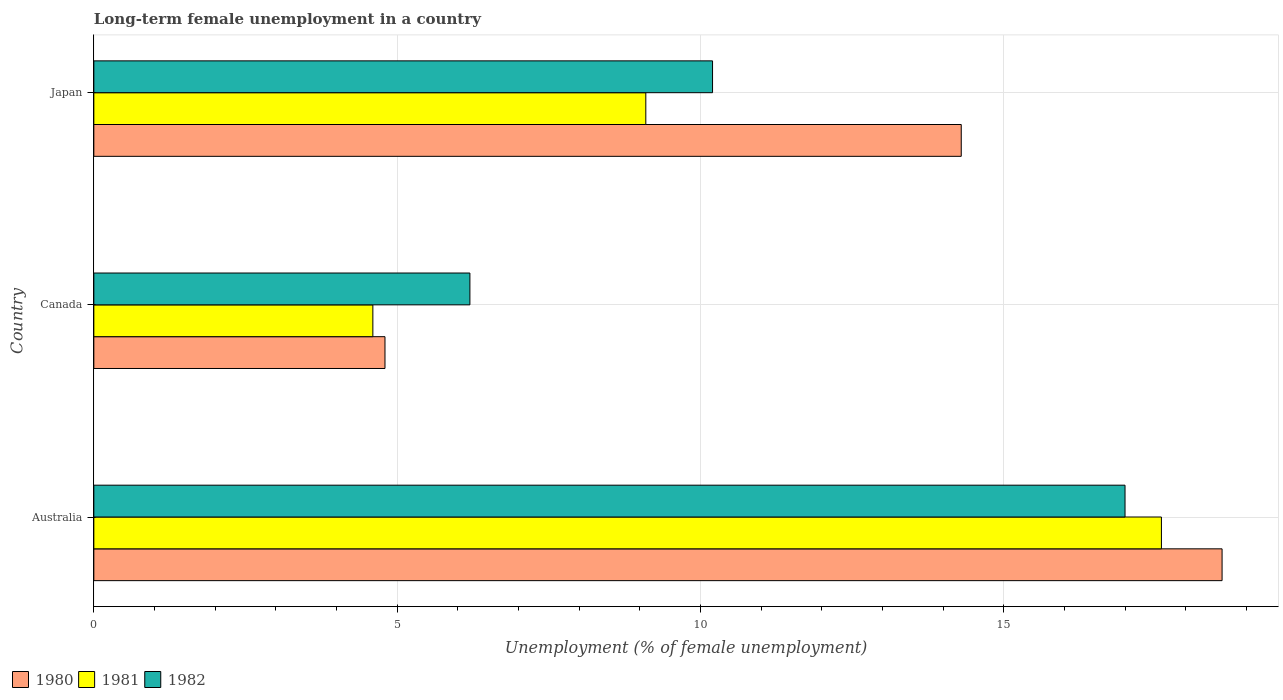How many groups of bars are there?
Offer a terse response. 3. What is the label of the 3rd group of bars from the top?
Your answer should be very brief. Australia. In how many cases, is the number of bars for a given country not equal to the number of legend labels?
Make the answer very short. 0. What is the percentage of long-term unemployed female population in 1980 in Japan?
Your answer should be compact. 14.3. Across all countries, what is the maximum percentage of long-term unemployed female population in 1981?
Keep it short and to the point. 17.6. Across all countries, what is the minimum percentage of long-term unemployed female population in 1982?
Give a very brief answer. 6.2. In which country was the percentage of long-term unemployed female population in 1981 maximum?
Offer a very short reply. Australia. In which country was the percentage of long-term unemployed female population in 1981 minimum?
Your answer should be compact. Canada. What is the total percentage of long-term unemployed female population in 1981 in the graph?
Give a very brief answer. 31.3. What is the difference between the percentage of long-term unemployed female population in 1980 in Australia and that in Japan?
Offer a terse response. 4.3. What is the difference between the percentage of long-term unemployed female population in 1980 in Japan and the percentage of long-term unemployed female population in 1981 in Australia?
Your response must be concise. -3.3. What is the average percentage of long-term unemployed female population in 1981 per country?
Give a very brief answer. 10.43. What is the difference between the percentage of long-term unemployed female population in 1981 and percentage of long-term unemployed female population in 1980 in Australia?
Make the answer very short. -1. In how many countries, is the percentage of long-term unemployed female population in 1981 greater than 9 %?
Give a very brief answer. 2. What is the ratio of the percentage of long-term unemployed female population in 1981 in Canada to that in Japan?
Keep it short and to the point. 0.51. Is the percentage of long-term unemployed female population in 1982 in Australia less than that in Japan?
Your response must be concise. No. Is the difference between the percentage of long-term unemployed female population in 1981 in Australia and Canada greater than the difference between the percentage of long-term unemployed female population in 1980 in Australia and Canada?
Offer a terse response. No. What is the difference between the highest and the second highest percentage of long-term unemployed female population in 1981?
Provide a succinct answer. 8.5. What is the difference between the highest and the lowest percentage of long-term unemployed female population in 1982?
Provide a succinct answer. 10.8. In how many countries, is the percentage of long-term unemployed female population in 1982 greater than the average percentage of long-term unemployed female population in 1982 taken over all countries?
Your answer should be very brief. 1. What does the 2nd bar from the bottom in Japan represents?
Your answer should be very brief. 1981. Are all the bars in the graph horizontal?
Your response must be concise. Yes. Does the graph contain any zero values?
Your answer should be compact. No. Where does the legend appear in the graph?
Provide a short and direct response. Bottom left. How many legend labels are there?
Make the answer very short. 3. How are the legend labels stacked?
Your answer should be compact. Horizontal. What is the title of the graph?
Offer a very short reply. Long-term female unemployment in a country. What is the label or title of the X-axis?
Your answer should be very brief. Unemployment (% of female unemployment). What is the label or title of the Y-axis?
Keep it short and to the point. Country. What is the Unemployment (% of female unemployment) of 1980 in Australia?
Your response must be concise. 18.6. What is the Unemployment (% of female unemployment) of 1981 in Australia?
Ensure brevity in your answer.  17.6. What is the Unemployment (% of female unemployment) of 1982 in Australia?
Your response must be concise. 17. What is the Unemployment (% of female unemployment) of 1980 in Canada?
Keep it short and to the point. 4.8. What is the Unemployment (% of female unemployment) in 1981 in Canada?
Make the answer very short. 4.6. What is the Unemployment (% of female unemployment) of 1982 in Canada?
Your response must be concise. 6.2. What is the Unemployment (% of female unemployment) in 1980 in Japan?
Provide a succinct answer. 14.3. What is the Unemployment (% of female unemployment) of 1981 in Japan?
Provide a succinct answer. 9.1. What is the Unemployment (% of female unemployment) in 1982 in Japan?
Offer a very short reply. 10.2. Across all countries, what is the maximum Unemployment (% of female unemployment) in 1980?
Ensure brevity in your answer.  18.6. Across all countries, what is the maximum Unemployment (% of female unemployment) of 1981?
Give a very brief answer. 17.6. Across all countries, what is the minimum Unemployment (% of female unemployment) in 1980?
Make the answer very short. 4.8. Across all countries, what is the minimum Unemployment (% of female unemployment) of 1981?
Ensure brevity in your answer.  4.6. Across all countries, what is the minimum Unemployment (% of female unemployment) of 1982?
Your response must be concise. 6.2. What is the total Unemployment (% of female unemployment) of 1980 in the graph?
Your response must be concise. 37.7. What is the total Unemployment (% of female unemployment) in 1981 in the graph?
Offer a terse response. 31.3. What is the total Unemployment (% of female unemployment) of 1982 in the graph?
Ensure brevity in your answer.  33.4. What is the difference between the Unemployment (% of female unemployment) in 1981 in Australia and that in Canada?
Offer a very short reply. 13. What is the difference between the Unemployment (% of female unemployment) of 1981 in Australia and that in Japan?
Provide a succinct answer. 8.5. What is the difference between the Unemployment (% of female unemployment) of 1982 in Australia and that in Japan?
Offer a very short reply. 6.8. What is the difference between the Unemployment (% of female unemployment) in 1980 in Canada and that in Japan?
Keep it short and to the point. -9.5. What is the difference between the Unemployment (% of female unemployment) of 1982 in Canada and that in Japan?
Offer a very short reply. -4. What is the difference between the Unemployment (% of female unemployment) in 1980 in Australia and the Unemployment (% of female unemployment) in 1981 in Canada?
Provide a succinct answer. 14. What is the difference between the Unemployment (% of female unemployment) of 1980 in Australia and the Unemployment (% of female unemployment) of 1982 in Canada?
Provide a short and direct response. 12.4. What is the difference between the Unemployment (% of female unemployment) in 1981 in Australia and the Unemployment (% of female unemployment) in 1982 in Canada?
Your answer should be very brief. 11.4. What is the difference between the Unemployment (% of female unemployment) of 1980 in Australia and the Unemployment (% of female unemployment) of 1981 in Japan?
Offer a very short reply. 9.5. What is the difference between the Unemployment (% of female unemployment) in 1980 in Australia and the Unemployment (% of female unemployment) in 1982 in Japan?
Offer a terse response. 8.4. What is the difference between the Unemployment (% of female unemployment) in 1980 in Canada and the Unemployment (% of female unemployment) in 1982 in Japan?
Give a very brief answer. -5.4. What is the difference between the Unemployment (% of female unemployment) of 1981 in Canada and the Unemployment (% of female unemployment) of 1982 in Japan?
Provide a succinct answer. -5.6. What is the average Unemployment (% of female unemployment) in 1980 per country?
Give a very brief answer. 12.57. What is the average Unemployment (% of female unemployment) of 1981 per country?
Keep it short and to the point. 10.43. What is the average Unemployment (% of female unemployment) in 1982 per country?
Your answer should be very brief. 11.13. What is the difference between the Unemployment (% of female unemployment) in 1980 and Unemployment (% of female unemployment) in 1981 in Australia?
Your answer should be compact. 1. What is the difference between the Unemployment (% of female unemployment) in 1981 and Unemployment (% of female unemployment) in 1982 in Australia?
Your answer should be compact. 0.6. What is the difference between the Unemployment (% of female unemployment) of 1981 and Unemployment (% of female unemployment) of 1982 in Canada?
Offer a terse response. -1.6. What is the difference between the Unemployment (% of female unemployment) in 1980 and Unemployment (% of female unemployment) in 1982 in Japan?
Keep it short and to the point. 4.1. What is the ratio of the Unemployment (% of female unemployment) in 1980 in Australia to that in Canada?
Offer a terse response. 3.88. What is the ratio of the Unemployment (% of female unemployment) in 1981 in Australia to that in Canada?
Make the answer very short. 3.83. What is the ratio of the Unemployment (% of female unemployment) of 1982 in Australia to that in Canada?
Your answer should be compact. 2.74. What is the ratio of the Unemployment (% of female unemployment) of 1980 in Australia to that in Japan?
Keep it short and to the point. 1.3. What is the ratio of the Unemployment (% of female unemployment) of 1981 in Australia to that in Japan?
Provide a succinct answer. 1.93. What is the ratio of the Unemployment (% of female unemployment) of 1980 in Canada to that in Japan?
Offer a very short reply. 0.34. What is the ratio of the Unemployment (% of female unemployment) of 1981 in Canada to that in Japan?
Provide a short and direct response. 0.51. What is the ratio of the Unemployment (% of female unemployment) in 1982 in Canada to that in Japan?
Provide a succinct answer. 0.61. What is the difference between the highest and the second highest Unemployment (% of female unemployment) in 1980?
Provide a short and direct response. 4.3. What is the difference between the highest and the lowest Unemployment (% of female unemployment) in 1982?
Keep it short and to the point. 10.8. 